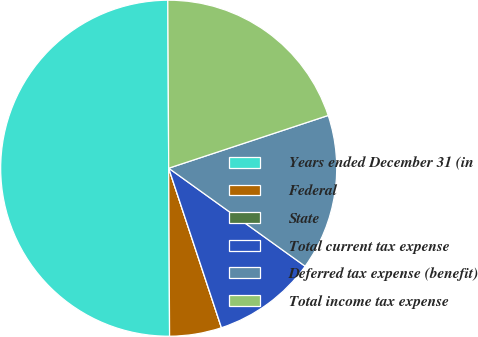<chart> <loc_0><loc_0><loc_500><loc_500><pie_chart><fcel>Years ended December 31 (in<fcel>Federal<fcel>State<fcel>Total current tax expense<fcel>Deferred tax expense (benefit)<fcel>Total income tax expense<nl><fcel>50.0%<fcel>5.0%<fcel>0.0%<fcel>10.0%<fcel>15.0%<fcel>20.0%<nl></chart> 